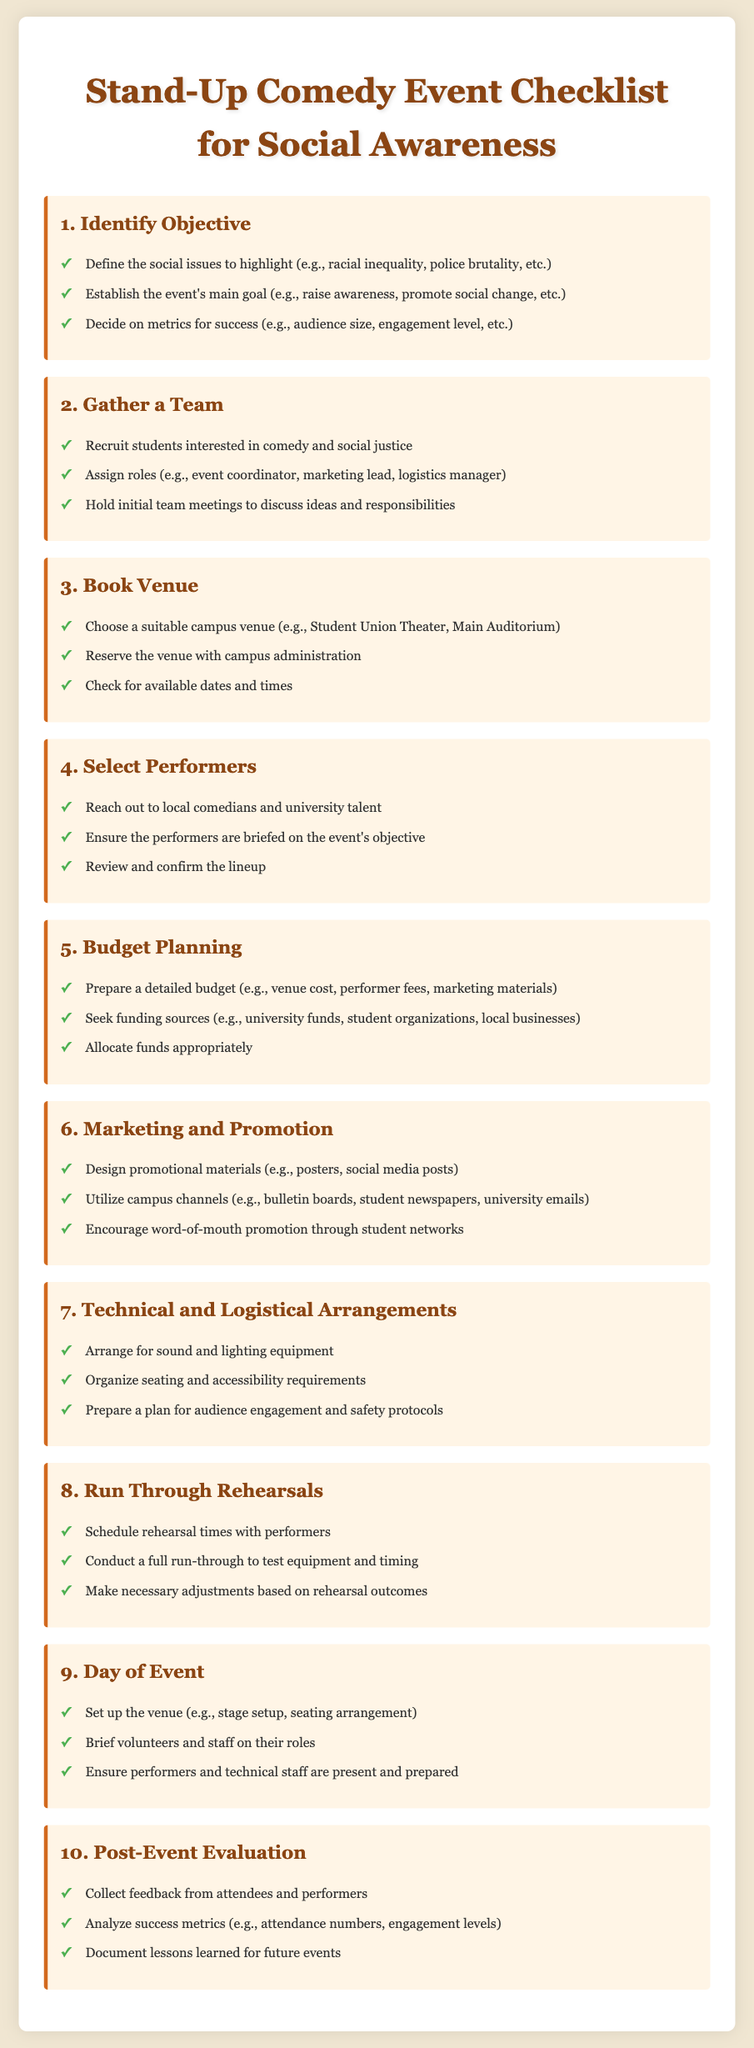what is the first step in organizing a stand-up comedy event? The first step is to identify the objective of the event.
Answer: Identify Objective how many checklist items are listed in the document? The document contains a total of ten checklist items.
Answer: 10 what should be done on the day of the event? On the day of the event, the venue should be set up, volunteers briefed, and performers ensured to be present.
Answer: Set up the venue which team roles are suggested for event organization? Suggested roles include event coordinator, marketing lead, and logistics manager.
Answer: Coordinator, lead, manager what is one of the metrics for success mentioned in the document? One metric for success mentioned is audience size.
Answer: Audience size why is a rehearsal important for the event? Rehearsals are important to test equipment, timing, and make necessary adjustments.
Answer: Test equipment who should be recruited for organizing the event? Students interested in comedy and social justice should be recruited.
Answer: Students what should be collected post-event? Feedback from attendees and performers should be collected post-event.
Answer: Feedback where should promotional materials be utilized? Promotional materials should be utilized in campus channels, such as bulletin boards and student newspapers.
Answer: Campus channels 